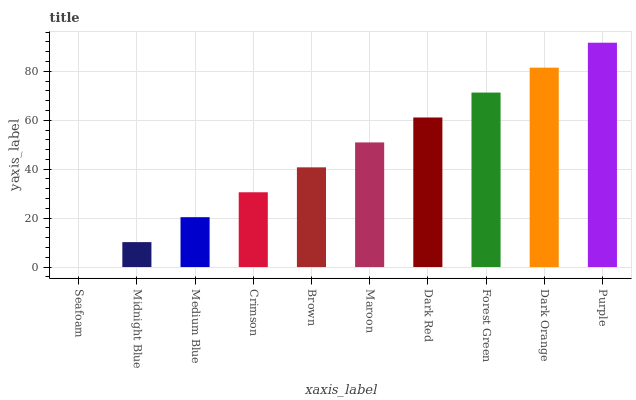Is Midnight Blue the minimum?
Answer yes or no. No. Is Midnight Blue the maximum?
Answer yes or no. No. Is Midnight Blue greater than Seafoam?
Answer yes or no. Yes. Is Seafoam less than Midnight Blue?
Answer yes or no. Yes. Is Seafoam greater than Midnight Blue?
Answer yes or no. No. Is Midnight Blue less than Seafoam?
Answer yes or no. No. Is Maroon the high median?
Answer yes or no. Yes. Is Brown the low median?
Answer yes or no. Yes. Is Dark Orange the high median?
Answer yes or no. No. Is Crimson the low median?
Answer yes or no. No. 